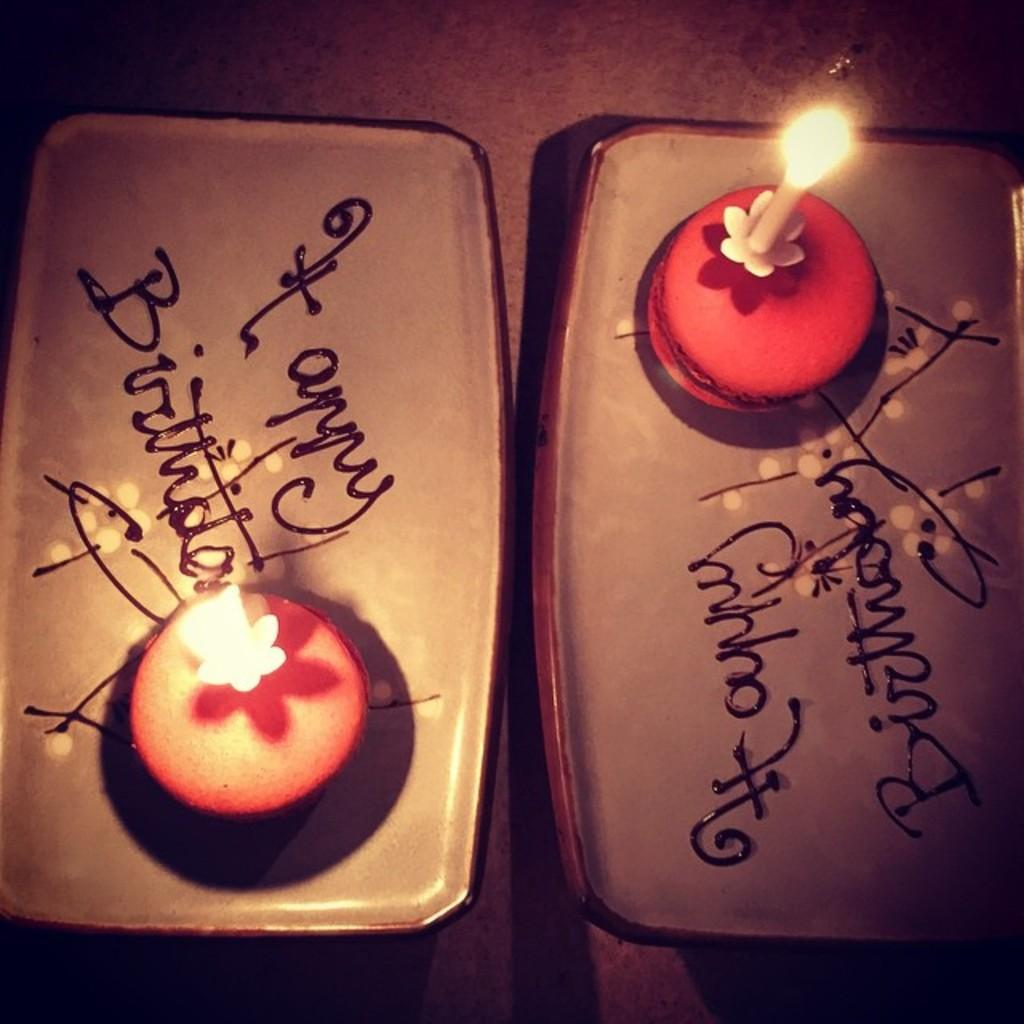What objects are present on both sides of the image? There are trays on the right and left side of the image. What message is written on the trays? The trays have "happy birthday" written on them. What can be seen on the trays along with the message? There are candles on the right and left side of the image. What type of ship is sailing in the background of the image? There is no ship visible in the image; it only features trays with candles and the "happy birthday" message. How old is the daughter being celebrated in the image? There is no information about a daughter or her age in the image. 